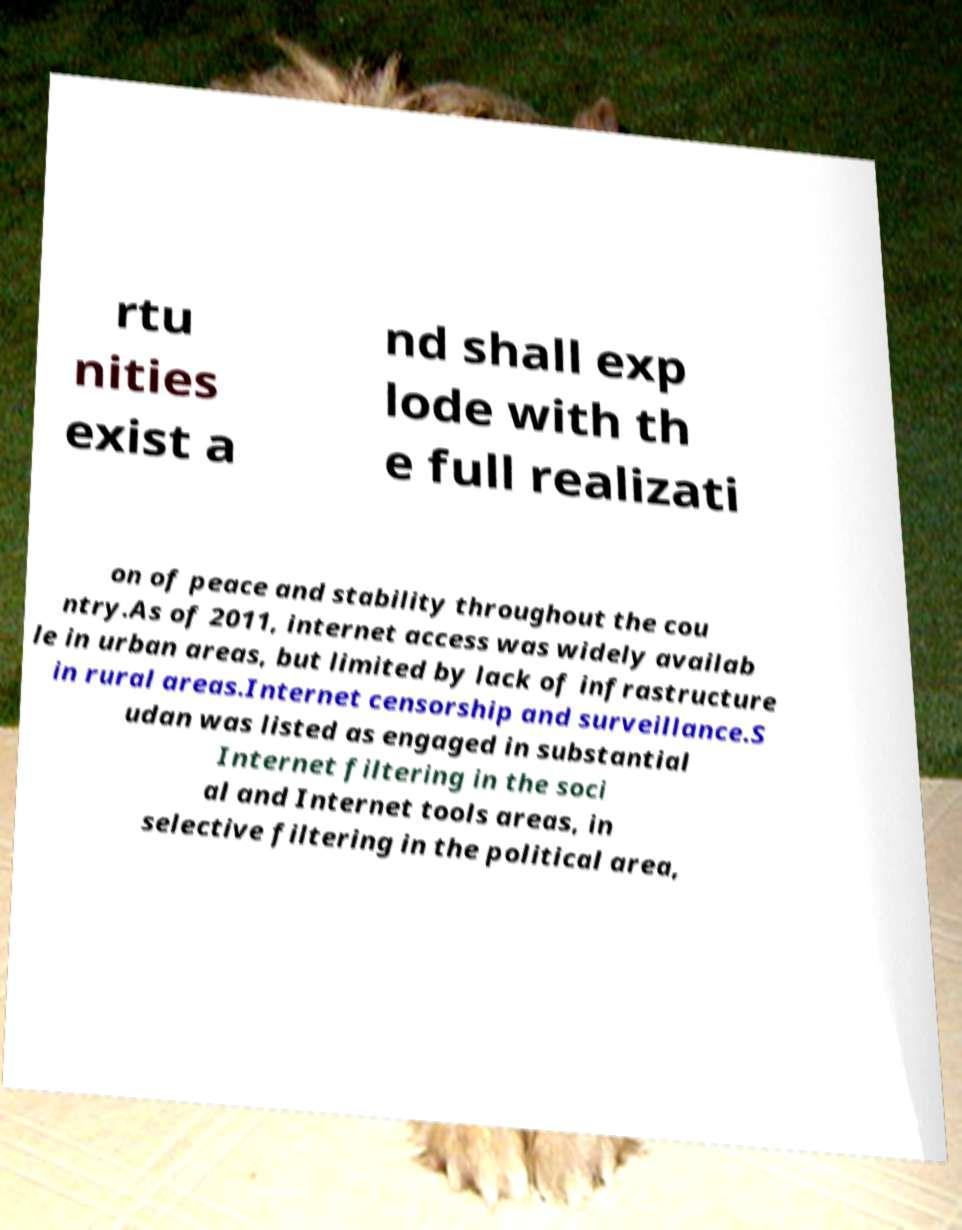I need the written content from this picture converted into text. Can you do that? rtu nities exist a nd shall exp lode with th e full realizati on of peace and stability throughout the cou ntry.As of 2011, internet access was widely availab le in urban areas, but limited by lack of infrastructure in rural areas.Internet censorship and surveillance.S udan was listed as engaged in substantial Internet filtering in the soci al and Internet tools areas, in selective filtering in the political area, 